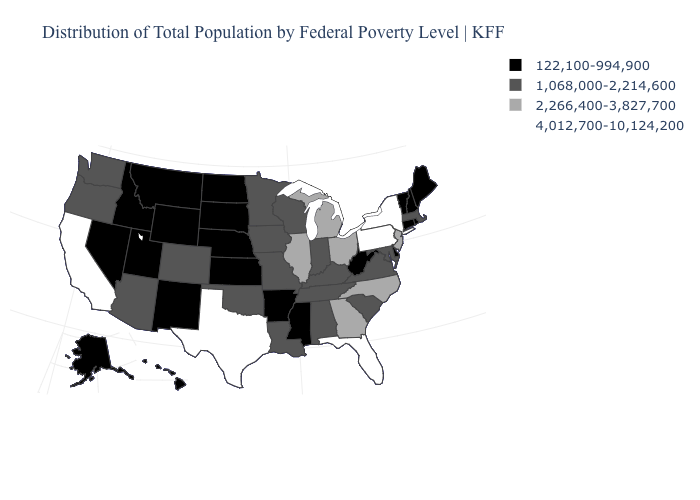Name the states that have a value in the range 1,068,000-2,214,600?
Quick response, please. Alabama, Arizona, Colorado, Indiana, Iowa, Kentucky, Louisiana, Maryland, Massachusetts, Minnesota, Missouri, Oklahoma, Oregon, South Carolina, Tennessee, Virginia, Washington, Wisconsin. Name the states that have a value in the range 1,068,000-2,214,600?
Quick response, please. Alabama, Arizona, Colorado, Indiana, Iowa, Kentucky, Louisiana, Maryland, Massachusetts, Minnesota, Missouri, Oklahoma, Oregon, South Carolina, Tennessee, Virginia, Washington, Wisconsin. What is the lowest value in states that border Indiana?
Give a very brief answer. 1,068,000-2,214,600. Name the states that have a value in the range 1,068,000-2,214,600?
Write a very short answer. Alabama, Arizona, Colorado, Indiana, Iowa, Kentucky, Louisiana, Maryland, Massachusetts, Minnesota, Missouri, Oklahoma, Oregon, South Carolina, Tennessee, Virginia, Washington, Wisconsin. Among the states that border Wyoming , does Colorado have the highest value?
Give a very brief answer. Yes. Which states hav the highest value in the Northeast?
Give a very brief answer. New York, Pennsylvania. What is the value of Maine?
Concise answer only. 122,100-994,900. Which states hav the highest value in the MidWest?
Be succinct. Illinois, Michigan, Ohio. Which states have the lowest value in the South?
Short answer required. Arkansas, Delaware, Mississippi, West Virginia. What is the value of New Hampshire?
Answer briefly. 122,100-994,900. Does the map have missing data?
Keep it brief. No. How many symbols are there in the legend?
Short answer required. 4. Name the states that have a value in the range 122,100-994,900?
Give a very brief answer. Alaska, Arkansas, Connecticut, Delaware, Hawaii, Idaho, Kansas, Maine, Mississippi, Montana, Nebraska, Nevada, New Hampshire, New Mexico, North Dakota, Rhode Island, South Dakota, Utah, Vermont, West Virginia, Wyoming. Name the states that have a value in the range 122,100-994,900?
Answer briefly. Alaska, Arkansas, Connecticut, Delaware, Hawaii, Idaho, Kansas, Maine, Mississippi, Montana, Nebraska, Nevada, New Hampshire, New Mexico, North Dakota, Rhode Island, South Dakota, Utah, Vermont, West Virginia, Wyoming. Which states have the lowest value in the USA?
Quick response, please. Alaska, Arkansas, Connecticut, Delaware, Hawaii, Idaho, Kansas, Maine, Mississippi, Montana, Nebraska, Nevada, New Hampshire, New Mexico, North Dakota, Rhode Island, South Dakota, Utah, Vermont, West Virginia, Wyoming. 